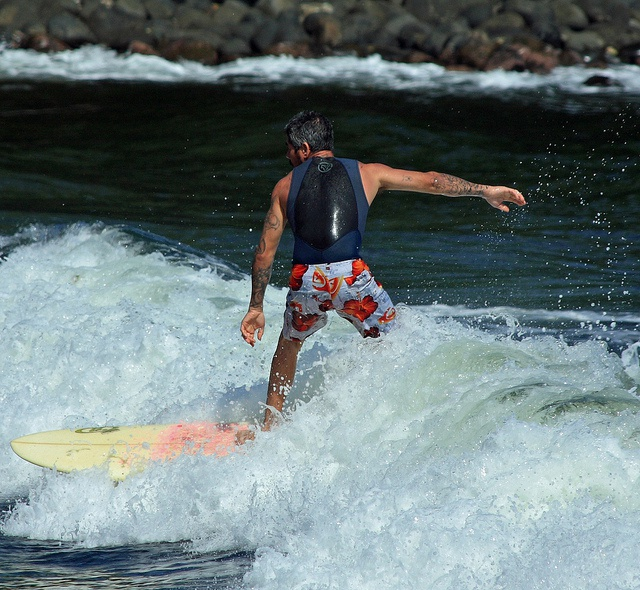Describe the objects in this image and their specific colors. I can see people in black, gray, brown, and maroon tones and surfboard in black, beige, lightpink, lightgray, and darkgray tones in this image. 